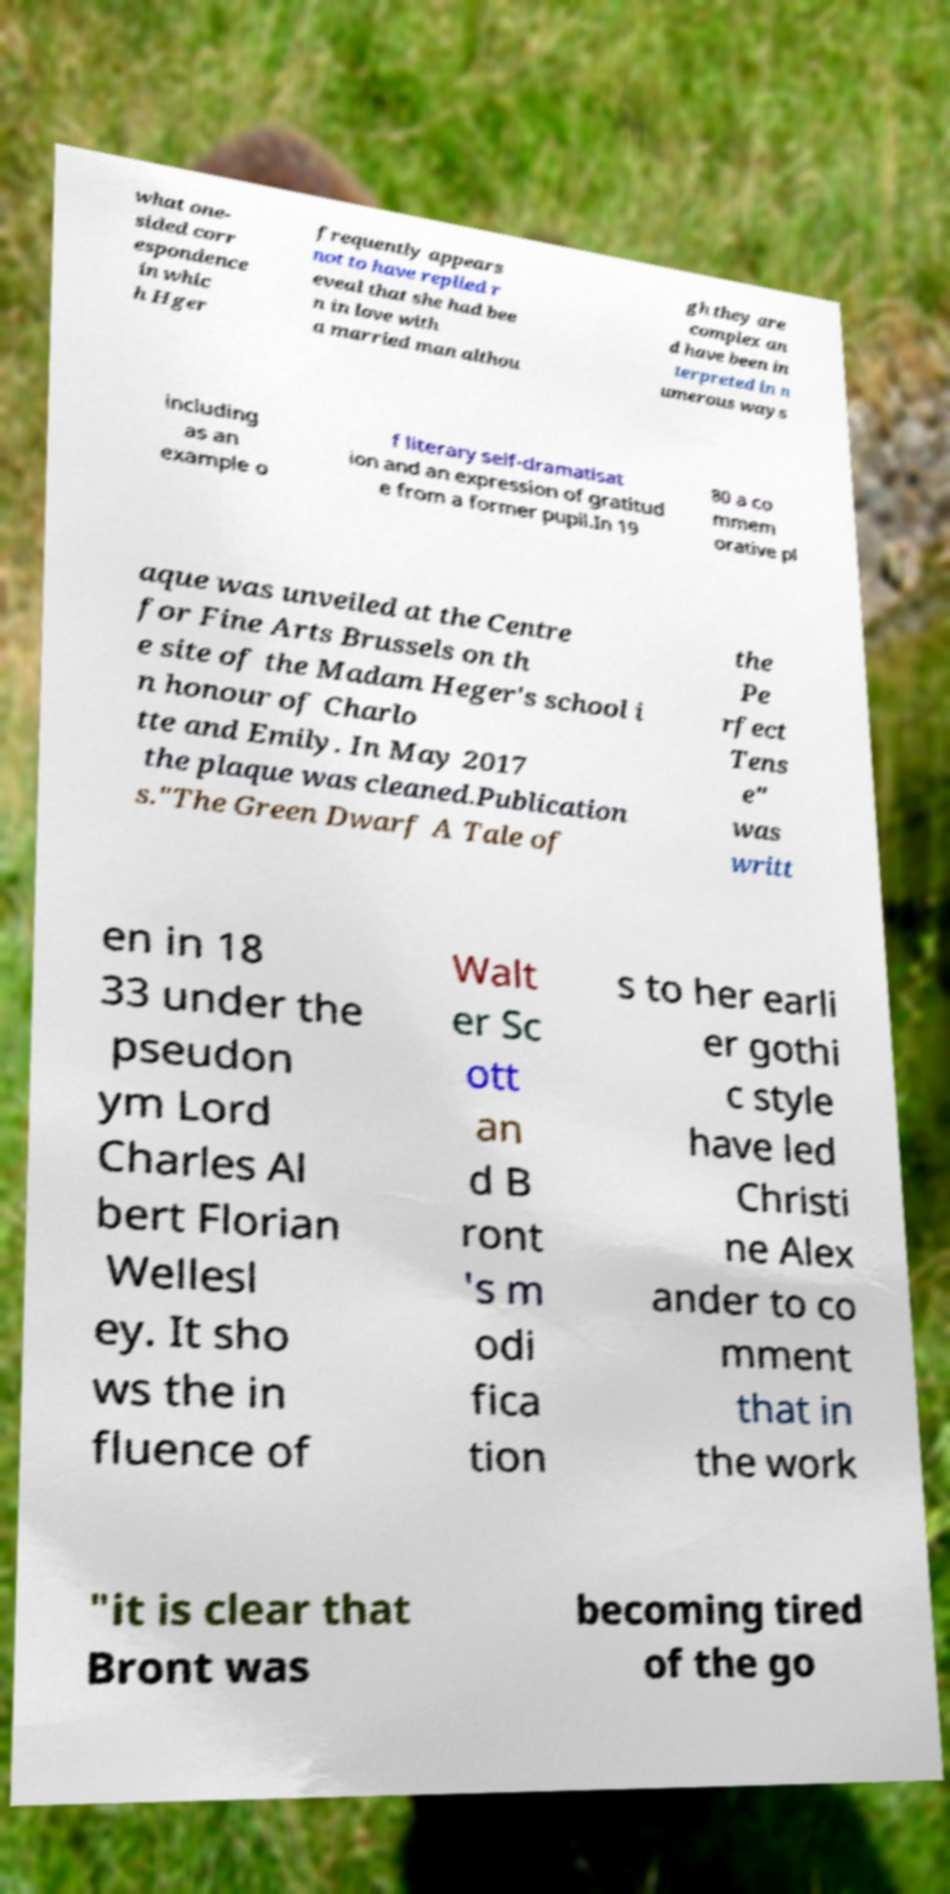Please identify and transcribe the text found in this image. what one- sided corr espondence in whic h Hger frequently appears not to have replied r eveal that she had bee n in love with a married man althou gh they are complex an d have been in terpreted in n umerous ways including as an example o f literary self-dramatisat ion and an expression of gratitud e from a former pupil.In 19 80 a co mmem orative pl aque was unveiled at the Centre for Fine Arts Brussels on th e site of the Madam Heger's school i n honour of Charlo tte and Emily. In May 2017 the plaque was cleaned.Publication s."The Green Dwarf A Tale of the Pe rfect Tens e" was writt en in 18 33 under the pseudon ym Lord Charles Al bert Florian Wellesl ey. It sho ws the in fluence of Walt er Sc ott an d B ront 's m odi fica tion s to her earli er gothi c style have led Christi ne Alex ander to co mment that in the work "it is clear that Bront was becoming tired of the go 